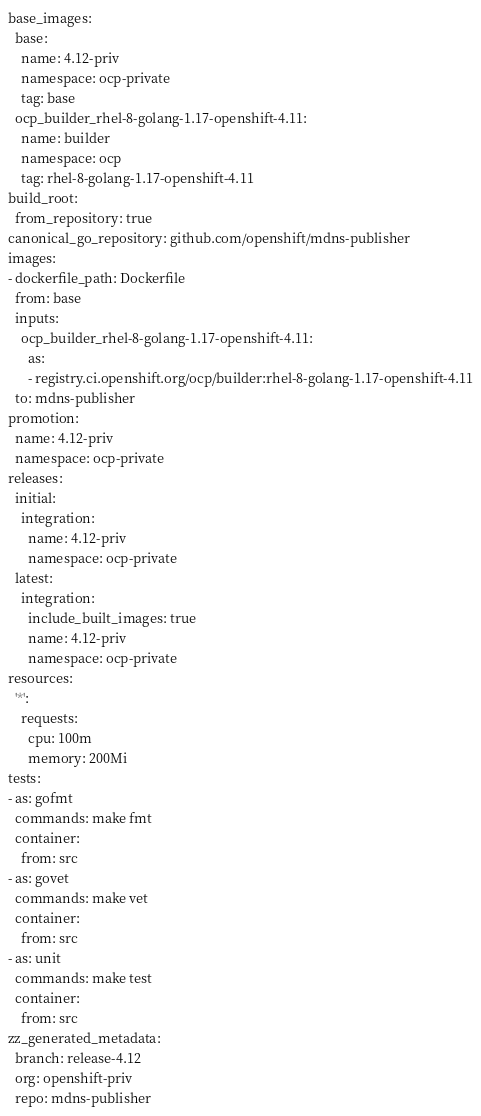Convert code to text. <code><loc_0><loc_0><loc_500><loc_500><_YAML_>base_images:
  base:
    name: 4.12-priv
    namespace: ocp-private
    tag: base
  ocp_builder_rhel-8-golang-1.17-openshift-4.11:
    name: builder
    namespace: ocp
    tag: rhel-8-golang-1.17-openshift-4.11
build_root:
  from_repository: true
canonical_go_repository: github.com/openshift/mdns-publisher
images:
- dockerfile_path: Dockerfile
  from: base
  inputs:
    ocp_builder_rhel-8-golang-1.17-openshift-4.11:
      as:
      - registry.ci.openshift.org/ocp/builder:rhel-8-golang-1.17-openshift-4.11
  to: mdns-publisher
promotion:
  name: 4.12-priv
  namespace: ocp-private
releases:
  initial:
    integration:
      name: 4.12-priv
      namespace: ocp-private
  latest:
    integration:
      include_built_images: true
      name: 4.12-priv
      namespace: ocp-private
resources:
  '*':
    requests:
      cpu: 100m
      memory: 200Mi
tests:
- as: gofmt
  commands: make fmt
  container:
    from: src
- as: govet
  commands: make vet
  container:
    from: src
- as: unit
  commands: make test
  container:
    from: src
zz_generated_metadata:
  branch: release-4.12
  org: openshift-priv
  repo: mdns-publisher
</code> 